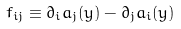Convert formula to latex. <formula><loc_0><loc_0><loc_500><loc_500>f _ { i j } \equiv \partial _ { i } a _ { j } ( y ) - \partial _ { j } a _ { i } ( y )</formula> 